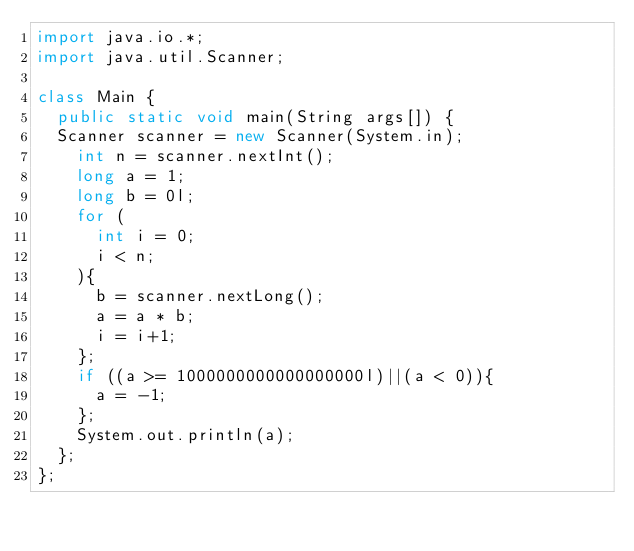Convert code to text. <code><loc_0><loc_0><loc_500><loc_500><_Java_>import java.io.*;
import java.util.Scanner;
 
class Main {
  public static void main(String args[]) {
	Scanner scanner = new Scanner(System.in);
    int n = scanner.nextInt();
    long a = 1;
    long b = 0l;
    for (
      int i = 0;
      i < n;
    ){
      b = scanner.nextLong();
      a = a * b;
      i = i+1;
    };
    if ((a >= 1000000000000000000l)||(a < 0)){
      a = -1;
    };
    System.out.println(a);
  };
};</code> 